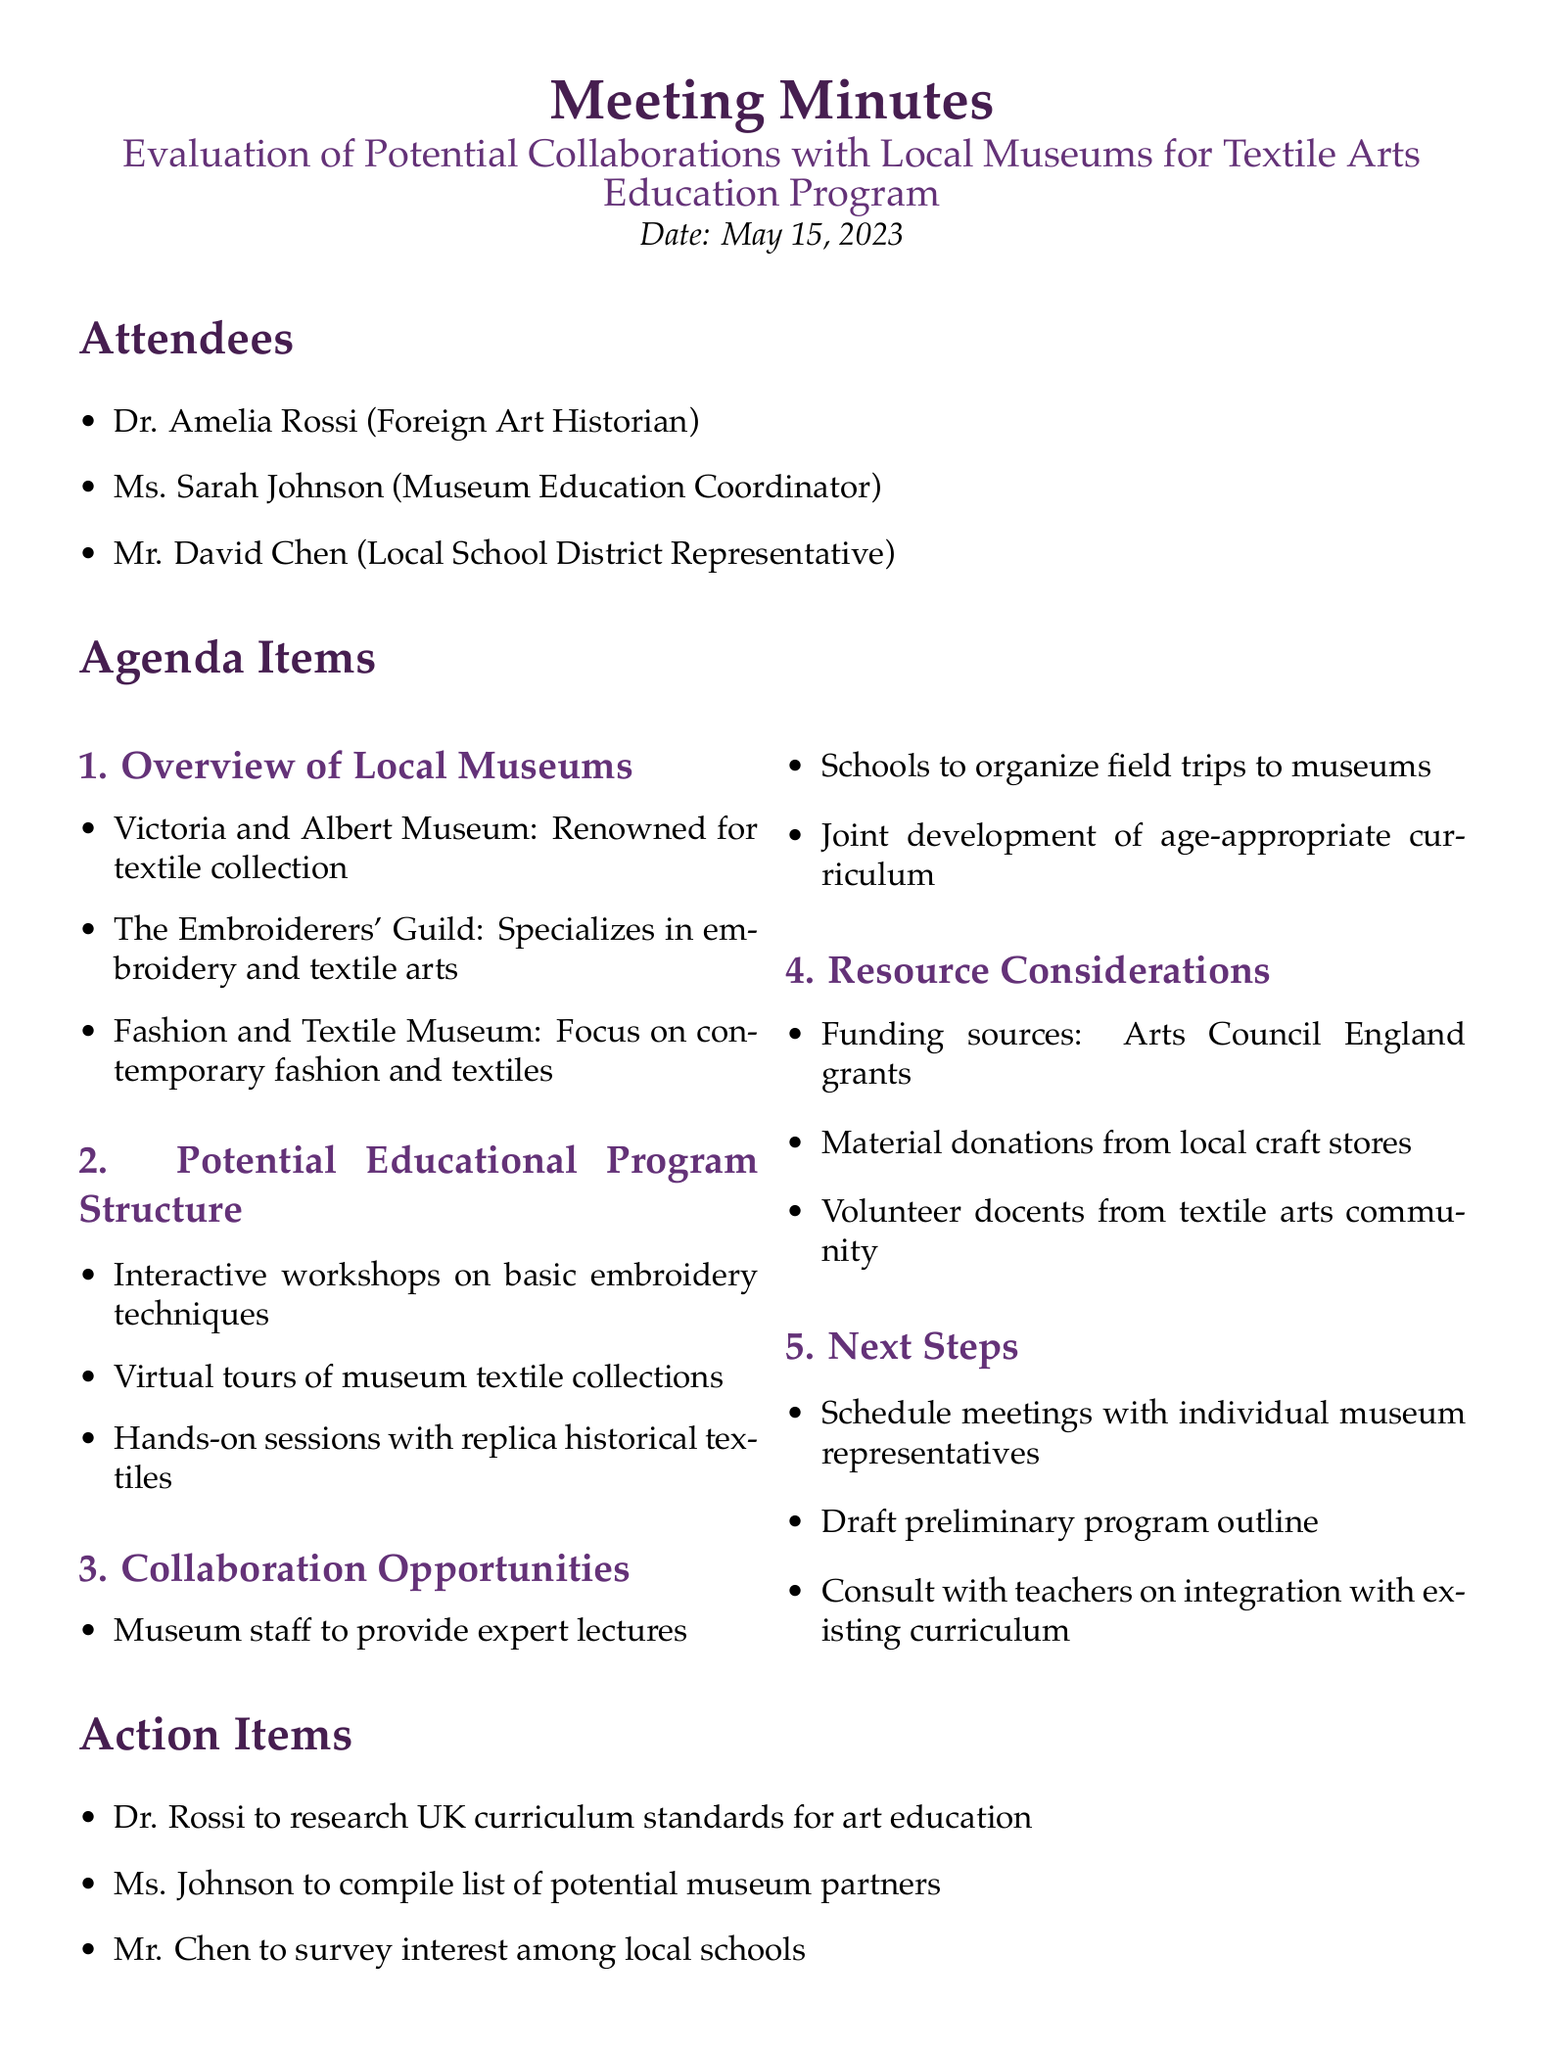What is the date of the meeting? The date is explicitly stated in the document as May 15, 2023.
Answer: May 15, 2023 Who is the Museum Education Coordinator? The attendees section lists Ms. Sarah Johnson as the Museum Education Coordinator.
Answer: Ms. Sarah Johnson Which museum specializes in embroidery? The "Overview of Local Museums" section specifies that The Embroiderers' Guild specializes in embroidery and textile arts.
Answer: The Embroiderers' Guild What funding source is mentioned? The document lists Arts Council England grants as a potential funding source under Resource Considerations.
Answer: Arts Council England grants What is one of the collaborative opportunities discussed? The document mentions that schools could organize field trips to museums as a collaboration opportunity.
Answer: Field trips What is the first action item listed? The action items section specifies that Dr. Rossi will research UK curriculum standards for art education as the first item.
Answer: Dr. Rossi to research UK curriculum standards for art education How many attendees were present at the meeting? The attendees section lists three individuals, indicating the number of attendees present.
Answer: Three What interactive activity is included in the program structure? The agenda item about the Potential Educational Program Structure includes interactive workshops on basic embroidery techniques as an activity.
Answer: Interactive workshops on basic embroidery techniques 